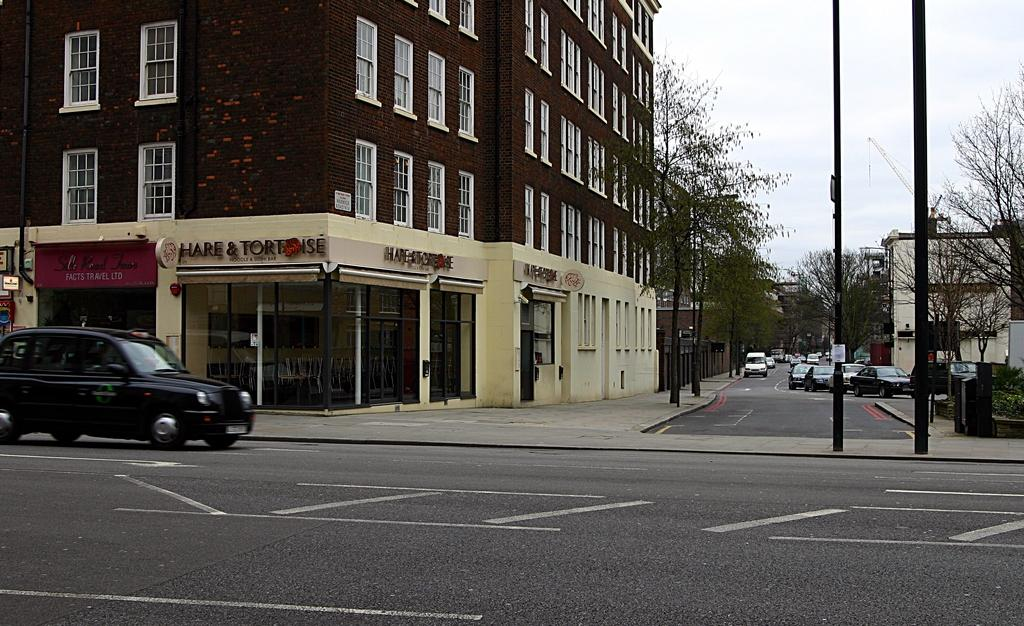<image>
Provide a brief description of the given image. A street scene shows the facade of a noodle restaurant. 